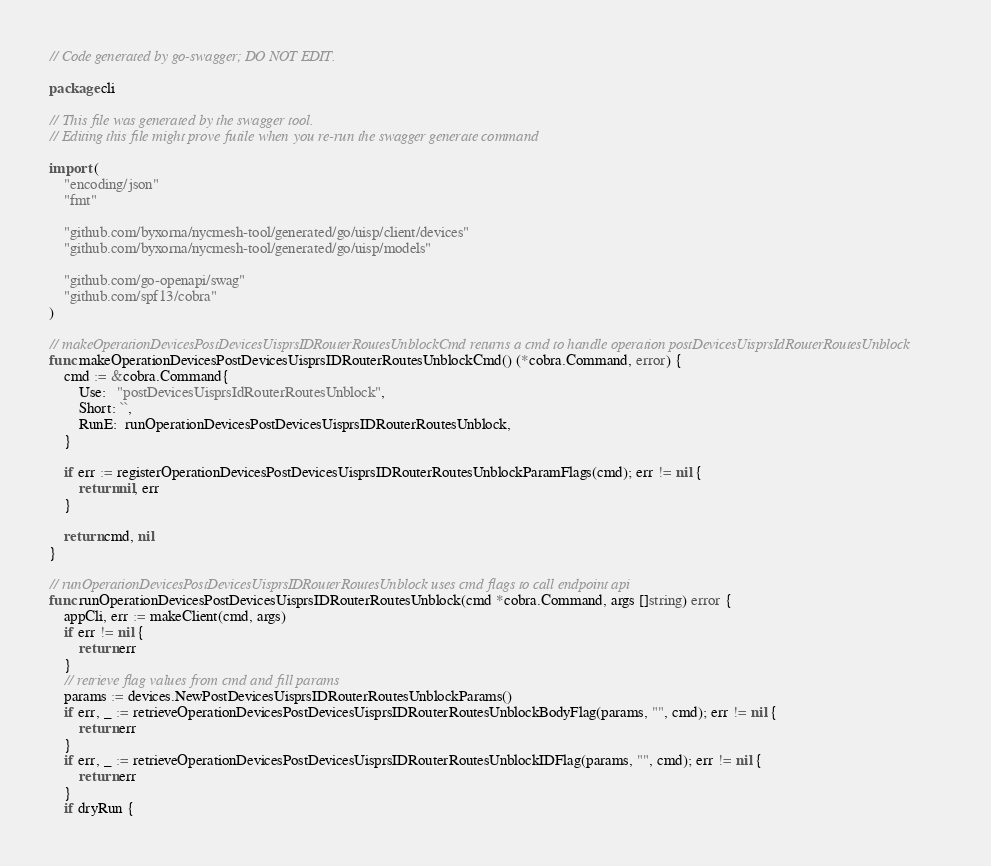Convert code to text. <code><loc_0><loc_0><loc_500><loc_500><_Go_>// Code generated by go-swagger; DO NOT EDIT.

package cli

// This file was generated by the swagger tool.
// Editing this file might prove futile when you re-run the swagger generate command

import (
	"encoding/json"
	"fmt"

	"github.com/byxorna/nycmesh-tool/generated/go/uisp/client/devices"
	"github.com/byxorna/nycmesh-tool/generated/go/uisp/models"

	"github.com/go-openapi/swag"
	"github.com/spf13/cobra"
)

// makeOperationDevicesPostDevicesUisprsIDRouterRoutesUnblockCmd returns a cmd to handle operation postDevicesUisprsIdRouterRoutesUnblock
func makeOperationDevicesPostDevicesUisprsIDRouterRoutesUnblockCmd() (*cobra.Command, error) {
	cmd := &cobra.Command{
		Use:   "postDevicesUisprsIdRouterRoutesUnblock",
		Short: ``,
		RunE:  runOperationDevicesPostDevicesUisprsIDRouterRoutesUnblock,
	}

	if err := registerOperationDevicesPostDevicesUisprsIDRouterRoutesUnblockParamFlags(cmd); err != nil {
		return nil, err
	}

	return cmd, nil
}

// runOperationDevicesPostDevicesUisprsIDRouterRoutesUnblock uses cmd flags to call endpoint api
func runOperationDevicesPostDevicesUisprsIDRouterRoutesUnblock(cmd *cobra.Command, args []string) error {
	appCli, err := makeClient(cmd, args)
	if err != nil {
		return err
	}
	// retrieve flag values from cmd and fill params
	params := devices.NewPostDevicesUisprsIDRouterRoutesUnblockParams()
	if err, _ := retrieveOperationDevicesPostDevicesUisprsIDRouterRoutesUnblockBodyFlag(params, "", cmd); err != nil {
		return err
	}
	if err, _ := retrieveOperationDevicesPostDevicesUisprsIDRouterRoutesUnblockIDFlag(params, "", cmd); err != nil {
		return err
	}
	if dryRun {
</code> 